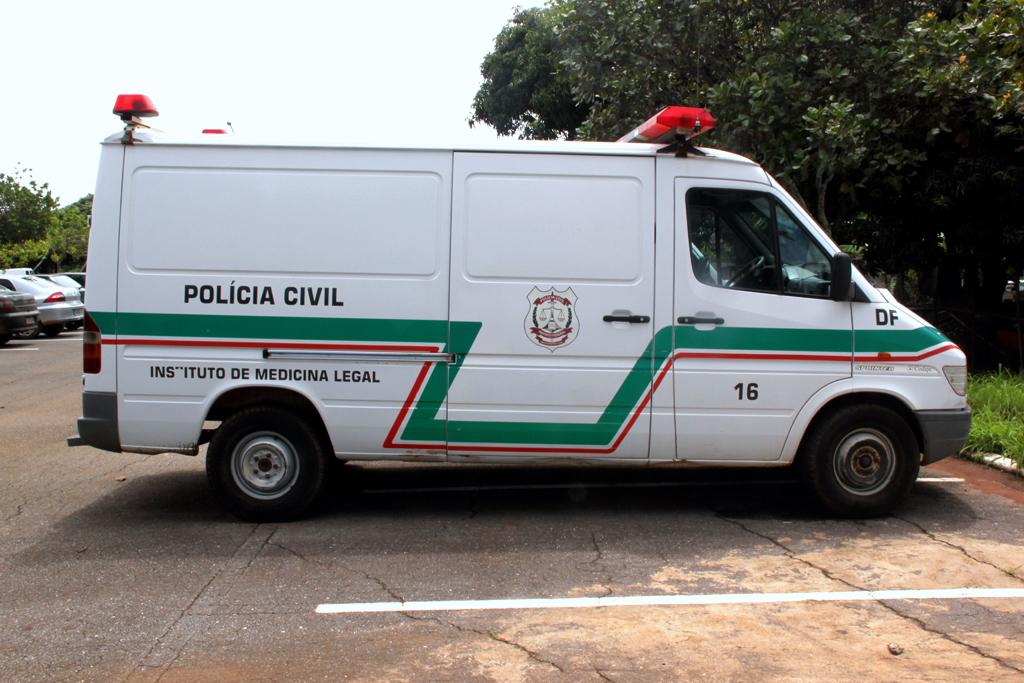What can be seen on the road in the image? There are vehicles on the road in the image. What type of vegetation is visible in the image? There are trees and grass visible in the image. What part of the natural environment is visible in the image? The sky is visible in the image. Can you see a stream flowing through the grass in the image? There is no stream visible in the image; only trees, grass, and vehicles on the road are present. What type of ornament is hanging from the trees in the image? There are no ornaments hanging from the trees in the image; only trees, grass, and vehicles on the road are present. 